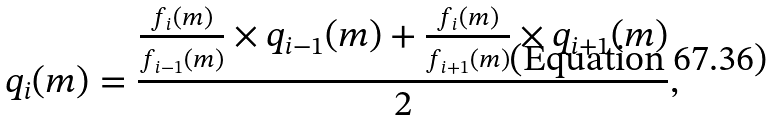Convert formula to latex. <formula><loc_0><loc_0><loc_500><loc_500>q _ { i } ( m ) = \frac { \frac { f _ { i } ( m ) } { f _ { i - 1 } ( m ) } \times q _ { i - 1 } ( m ) + \frac { f _ { i } ( m ) } { f _ { i + 1 } ( m ) } \times q _ { i + 1 } ( m ) } { 2 } ,</formula> 